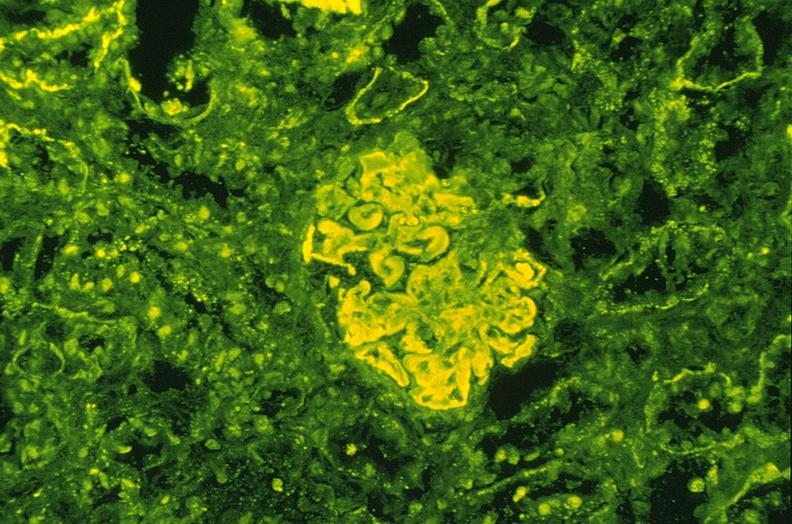s urinary present?
Answer the question using a single word or phrase. Yes 